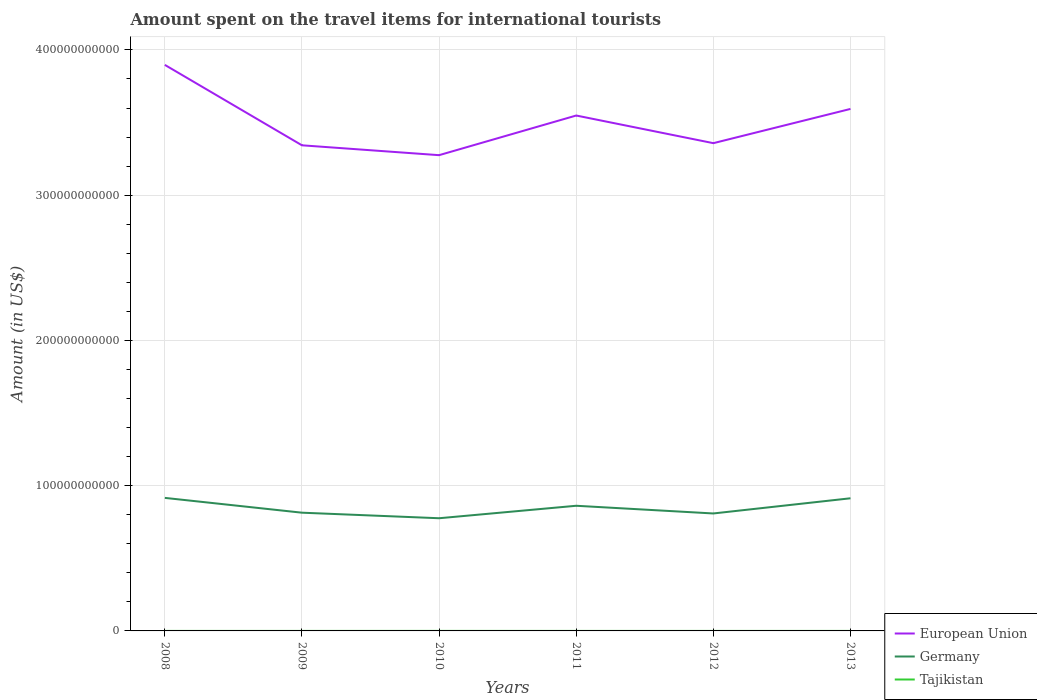Does the line corresponding to European Union intersect with the line corresponding to Germany?
Your answer should be very brief. No. Across all years, what is the maximum amount spent on the travel items for international tourists in European Union?
Your response must be concise. 3.28e+11. In which year was the amount spent on the travel items for international tourists in Germany maximum?
Your answer should be compact. 2010. What is the total amount spent on the travel items for international tourists in Germany in the graph?
Your answer should be compact. -4.76e+09. What is the difference between the highest and the second highest amount spent on the travel items for international tourists in European Union?
Keep it short and to the point. 6.22e+1. What is the difference between two consecutive major ticks on the Y-axis?
Ensure brevity in your answer.  1.00e+11. Are the values on the major ticks of Y-axis written in scientific E-notation?
Offer a terse response. No. How many legend labels are there?
Make the answer very short. 3. What is the title of the graph?
Give a very brief answer. Amount spent on the travel items for international tourists. What is the label or title of the X-axis?
Give a very brief answer. Years. What is the label or title of the Y-axis?
Your answer should be very brief. Amount (in US$). What is the Amount (in US$) of European Union in 2008?
Your answer should be compact. 3.90e+11. What is the Amount (in US$) of Germany in 2008?
Offer a very short reply. 9.16e+1. What is the Amount (in US$) of Tajikistan in 2008?
Make the answer very short. 1.08e+07. What is the Amount (in US$) of European Union in 2009?
Provide a short and direct response. 3.34e+11. What is the Amount (in US$) in Germany in 2009?
Give a very brief answer. 8.14e+1. What is the Amount (in US$) of Tajikistan in 2009?
Your answer should be very brief. 5.80e+06. What is the Amount (in US$) in European Union in 2010?
Your answer should be very brief. 3.28e+11. What is the Amount (in US$) of Germany in 2010?
Provide a succinct answer. 7.76e+1. What is the Amount (in US$) of Tajikistan in 2010?
Provide a short and direct response. 1.78e+07. What is the Amount (in US$) of European Union in 2011?
Offer a terse response. 3.55e+11. What is the Amount (in US$) in Germany in 2011?
Your answer should be compact. 8.62e+1. What is the Amount (in US$) in Tajikistan in 2011?
Give a very brief answer. 8.40e+06. What is the Amount (in US$) in European Union in 2012?
Offer a terse response. 3.36e+11. What is the Amount (in US$) of Germany in 2012?
Provide a succinct answer. 8.09e+1. What is the Amount (in US$) of Tajikistan in 2012?
Your response must be concise. 6.80e+06. What is the Amount (in US$) of European Union in 2013?
Your answer should be very brief. 3.59e+11. What is the Amount (in US$) of Germany in 2013?
Provide a short and direct response. 9.13e+1. What is the Amount (in US$) in Tajikistan in 2013?
Provide a short and direct response. 7.20e+06. Across all years, what is the maximum Amount (in US$) in European Union?
Give a very brief answer. 3.90e+11. Across all years, what is the maximum Amount (in US$) of Germany?
Your response must be concise. 9.16e+1. Across all years, what is the maximum Amount (in US$) in Tajikistan?
Ensure brevity in your answer.  1.78e+07. Across all years, what is the minimum Amount (in US$) of European Union?
Your response must be concise. 3.28e+11. Across all years, what is the minimum Amount (in US$) in Germany?
Provide a short and direct response. 7.76e+1. Across all years, what is the minimum Amount (in US$) of Tajikistan?
Provide a short and direct response. 5.80e+06. What is the total Amount (in US$) in European Union in the graph?
Your answer should be very brief. 2.10e+12. What is the total Amount (in US$) of Germany in the graph?
Keep it short and to the point. 5.09e+11. What is the total Amount (in US$) of Tajikistan in the graph?
Your response must be concise. 5.68e+07. What is the difference between the Amount (in US$) in European Union in 2008 and that in 2009?
Offer a very short reply. 5.54e+1. What is the difference between the Amount (in US$) of Germany in 2008 and that in 2009?
Give a very brief answer. 1.02e+1. What is the difference between the Amount (in US$) in Tajikistan in 2008 and that in 2009?
Give a very brief answer. 5.00e+06. What is the difference between the Amount (in US$) of European Union in 2008 and that in 2010?
Ensure brevity in your answer.  6.22e+1. What is the difference between the Amount (in US$) in Germany in 2008 and that in 2010?
Give a very brief answer. 1.40e+1. What is the difference between the Amount (in US$) of Tajikistan in 2008 and that in 2010?
Keep it short and to the point. -7.00e+06. What is the difference between the Amount (in US$) in European Union in 2008 and that in 2011?
Your answer should be very brief. 3.49e+1. What is the difference between the Amount (in US$) in Germany in 2008 and that in 2011?
Your answer should be compact. 5.43e+09. What is the difference between the Amount (in US$) in Tajikistan in 2008 and that in 2011?
Your response must be concise. 2.40e+06. What is the difference between the Amount (in US$) in European Union in 2008 and that in 2012?
Your answer should be compact. 5.39e+1. What is the difference between the Amount (in US$) in Germany in 2008 and that in 2012?
Offer a very short reply. 1.07e+1. What is the difference between the Amount (in US$) of Tajikistan in 2008 and that in 2012?
Provide a short and direct response. 4.00e+06. What is the difference between the Amount (in US$) of European Union in 2008 and that in 2013?
Make the answer very short. 3.03e+1. What is the difference between the Amount (in US$) of Germany in 2008 and that in 2013?
Your answer should be compact. 2.78e+08. What is the difference between the Amount (in US$) in Tajikistan in 2008 and that in 2013?
Your answer should be very brief. 3.60e+06. What is the difference between the Amount (in US$) in European Union in 2009 and that in 2010?
Your answer should be compact. 6.79e+09. What is the difference between the Amount (in US$) in Germany in 2009 and that in 2010?
Your answer should be very brief. 3.82e+09. What is the difference between the Amount (in US$) in Tajikistan in 2009 and that in 2010?
Offer a terse response. -1.20e+07. What is the difference between the Amount (in US$) in European Union in 2009 and that in 2011?
Give a very brief answer. -2.05e+1. What is the difference between the Amount (in US$) of Germany in 2009 and that in 2011?
Provide a short and direct response. -4.76e+09. What is the difference between the Amount (in US$) in Tajikistan in 2009 and that in 2011?
Offer a terse response. -2.60e+06. What is the difference between the Amount (in US$) of European Union in 2009 and that in 2012?
Ensure brevity in your answer.  -1.47e+09. What is the difference between the Amount (in US$) of Germany in 2009 and that in 2012?
Provide a succinct answer. 5.35e+08. What is the difference between the Amount (in US$) in Tajikistan in 2009 and that in 2012?
Offer a terse response. -1.00e+06. What is the difference between the Amount (in US$) of European Union in 2009 and that in 2013?
Your answer should be compact. -2.50e+1. What is the difference between the Amount (in US$) of Germany in 2009 and that in 2013?
Keep it short and to the point. -9.92e+09. What is the difference between the Amount (in US$) in Tajikistan in 2009 and that in 2013?
Your answer should be very brief. -1.40e+06. What is the difference between the Amount (in US$) of European Union in 2010 and that in 2011?
Provide a short and direct response. -2.73e+1. What is the difference between the Amount (in US$) of Germany in 2010 and that in 2011?
Make the answer very short. -8.59e+09. What is the difference between the Amount (in US$) in Tajikistan in 2010 and that in 2011?
Your answer should be compact. 9.40e+06. What is the difference between the Amount (in US$) in European Union in 2010 and that in 2012?
Provide a succinct answer. -8.26e+09. What is the difference between the Amount (in US$) of Germany in 2010 and that in 2012?
Offer a very short reply. -3.29e+09. What is the difference between the Amount (in US$) of Tajikistan in 2010 and that in 2012?
Provide a succinct answer. 1.10e+07. What is the difference between the Amount (in US$) of European Union in 2010 and that in 2013?
Your answer should be compact. -3.18e+1. What is the difference between the Amount (in US$) of Germany in 2010 and that in 2013?
Provide a succinct answer. -1.37e+1. What is the difference between the Amount (in US$) in Tajikistan in 2010 and that in 2013?
Offer a very short reply. 1.06e+07. What is the difference between the Amount (in US$) in European Union in 2011 and that in 2012?
Offer a very short reply. 1.90e+1. What is the difference between the Amount (in US$) of Germany in 2011 and that in 2012?
Give a very brief answer. 5.30e+09. What is the difference between the Amount (in US$) in Tajikistan in 2011 and that in 2012?
Provide a short and direct response. 1.60e+06. What is the difference between the Amount (in US$) of European Union in 2011 and that in 2013?
Make the answer very short. -4.54e+09. What is the difference between the Amount (in US$) of Germany in 2011 and that in 2013?
Provide a succinct answer. -5.15e+09. What is the difference between the Amount (in US$) in Tajikistan in 2011 and that in 2013?
Offer a very short reply. 1.20e+06. What is the difference between the Amount (in US$) of European Union in 2012 and that in 2013?
Provide a short and direct response. -2.36e+1. What is the difference between the Amount (in US$) of Germany in 2012 and that in 2013?
Provide a short and direct response. -1.05e+1. What is the difference between the Amount (in US$) in Tajikistan in 2012 and that in 2013?
Offer a very short reply. -4.00e+05. What is the difference between the Amount (in US$) in European Union in 2008 and the Amount (in US$) in Germany in 2009?
Keep it short and to the point. 3.08e+11. What is the difference between the Amount (in US$) of European Union in 2008 and the Amount (in US$) of Tajikistan in 2009?
Provide a short and direct response. 3.90e+11. What is the difference between the Amount (in US$) in Germany in 2008 and the Amount (in US$) in Tajikistan in 2009?
Offer a very short reply. 9.16e+1. What is the difference between the Amount (in US$) of European Union in 2008 and the Amount (in US$) of Germany in 2010?
Your response must be concise. 3.12e+11. What is the difference between the Amount (in US$) in European Union in 2008 and the Amount (in US$) in Tajikistan in 2010?
Your answer should be very brief. 3.90e+11. What is the difference between the Amount (in US$) of Germany in 2008 and the Amount (in US$) of Tajikistan in 2010?
Keep it short and to the point. 9.16e+1. What is the difference between the Amount (in US$) of European Union in 2008 and the Amount (in US$) of Germany in 2011?
Your answer should be compact. 3.04e+11. What is the difference between the Amount (in US$) in European Union in 2008 and the Amount (in US$) in Tajikistan in 2011?
Your response must be concise. 3.90e+11. What is the difference between the Amount (in US$) of Germany in 2008 and the Amount (in US$) of Tajikistan in 2011?
Make the answer very short. 9.16e+1. What is the difference between the Amount (in US$) in European Union in 2008 and the Amount (in US$) in Germany in 2012?
Offer a very short reply. 3.09e+11. What is the difference between the Amount (in US$) of European Union in 2008 and the Amount (in US$) of Tajikistan in 2012?
Your answer should be compact. 3.90e+11. What is the difference between the Amount (in US$) in Germany in 2008 and the Amount (in US$) in Tajikistan in 2012?
Keep it short and to the point. 9.16e+1. What is the difference between the Amount (in US$) of European Union in 2008 and the Amount (in US$) of Germany in 2013?
Provide a succinct answer. 2.98e+11. What is the difference between the Amount (in US$) in European Union in 2008 and the Amount (in US$) in Tajikistan in 2013?
Offer a very short reply. 3.90e+11. What is the difference between the Amount (in US$) in Germany in 2008 and the Amount (in US$) in Tajikistan in 2013?
Offer a very short reply. 9.16e+1. What is the difference between the Amount (in US$) in European Union in 2009 and the Amount (in US$) in Germany in 2010?
Keep it short and to the point. 2.57e+11. What is the difference between the Amount (in US$) in European Union in 2009 and the Amount (in US$) in Tajikistan in 2010?
Provide a succinct answer. 3.34e+11. What is the difference between the Amount (in US$) in Germany in 2009 and the Amount (in US$) in Tajikistan in 2010?
Provide a succinct answer. 8.14e+1. What is the difference between the Amount (in US$) of European Union in 2009 and the Amount (in US$) of Germany in 2011?
Provide a short and direct response. 2.48e+11. What is the difference between the Amount (in US$) of European Union in 2009 and the Amount (in US$) of Tajikistan in 2011?
Your answer should be very brief. 3.34e+11. What is the difference between the Amount (in US$) in Germany in 2009 and the Amount (in US$) in Tajikistan in 2011?
Ensure brevity in your answer.  8.14e+1. What is the difference between the Amount (in US$) in European Union in 2009 and the Amount (in US$) in Germany in 2012?
Give a very brief answer. 2.53e+11. What is the difference between the Amount (in US$) in European Union in 2009 and the Amount (in US$) in Tajikistan in 2012?
Provide a short and direct response. 3.34e+11. What is the difference between the Amount (in US$) in Germany in 2009 and the Amount (in US$) in Tajikistan in 2012?
Make the answer very short. 8.14e+1. What is the difference between the Amount (in US$) in European Union in 2009 and the Amount (in US$) in Germany in 2013?
Your response must be concise. 2.43e+11. What is the difference between the Amount (in US$) in European Union in 2009 and the Amount (in US$) in Tajikistan in 2013?
Offer a very short reply. 3.34e+11. What is the difference between the Amount (in US$) in Germany in 2009 and the Amount (in US$) in Tajikistan in 2013?
Provide a short and direct response. 8.14e+1. What is the difference between the Amount (in US$) in European Union in 2010 and the Amount (in US$) in Germany in 2011?
Your answer should be very brief. 2.41e+11. What is the difference between the Amount (in US$) in European Union in 2010 and the Amount (in US$) in Tajikistan in 2011?
Make the answer very short. 3.28e+11. What is the difference between the Amount (in US$) in Germany in 2010 and the Amount (in US$) in Tajikistan in 2011?
Your answer should be very brief. 7.76e+1. What is the difference between the Amount (in US$) of European Union in 2010 and the Amount (in US$) of Germany in 2012?
Provide a succinct answer. 2.47e+11. What is the difference between the Amount (in US$) of European Union in 2010 and the Amount (in US$) of Tajikistan in 2012?
Offer a very short reply. 3.28e+11. What is the difference between the Amount (in US$) in Germany in 2010 and the Amount (in US$) in Tajikistan in 2012?
Your response must be concise. 7.76e+1. What is the difference between the Amount (in US$) of European Union in 2010 and the Amount (in US$) of Germany in 2013?
Offer a very short reply. 2.36e+11. What is the difference between the Amount (in US$) in European Union in 2010 and the Amount (in US$) in Tajikistan in 2013?
Keep it short and to the point. 3.28e+11. What is the difference between the Amount (in US$) in Germany in 2010 and the Amount (in US$) in Tajikistan in 2013?
Your answer should be compact. 7.76e+1. What is the difference between the Amount (in US$) in European Union in 2011 and the Amount (in US$) in Germany in 2012?
Your answer should be compact. 2.74e+11. What is the difference between the Amount (in US$) in European Union in 2011 and the Amount (in US$) in Tajikistan in 2012?
Offer a terse response. 3.55e+11. What is the difference between the Amount (in US$) of Germany in 2011 and the Amount (in US$) of Tajikistan in 2012?
Provide a short and direct response. 8.62e+1. What is the difference between the Amount (in US$) in European Union in 2011 and the Amount (in US$) in Germany in 2013?
Your response must be concise. 2.64e+11. What is the difference between the Amount (in US$) in European Union in 2011 and the Amount (in US$) in Tajikistan in 2013?
Provide a short and direct response. 3.55e+11. What is the difference between the Amount (in US$) in Germany in 2011 and the Amount (in US$) in Tajikistan in 2013?
Make the answer very short. 8.62e+1. What is the difference between the Amount (in US$) in European Union in 2012 and the Amount (in US$) in Germany in 2013?
Keep it short and to the point. 2.44e+11. What is the difference between the Amount (in US$) in European Union in 2012 and the Amount (in US$) in Tajikistan in 2013?
Provide a succinct answer. 3.36e+11. What is the difference between the Amount (in US$) of Germany in 2012 and the Amount (in US$) of Tajikistan in 2013?
Provide a short and direct response. 8.09e+1. What is the average Amount (in US$) in European Union per year?
Give a very brief answer. 3.50e+11. What is the average Amount (in US$) of Germany per year?
Provide a succinct answer. 8.48e+1. What is the average Amount (in US$) in Tajikistan per year?
Make the answer very short. 9.47e+06. In the year 2008, what is the difference between the Amount (in US$) in European Union and Amount (in US$) in Germany?
Keep it short and to the point. 2.98e+11. In the year 2008, what is the difference between the Amount (in US$) in European Union and Amount (in US$) in Tajikistan?
Provide a short and direct response. 3.90e+11. In the year 2008, what is the difference between the Amount (in US$) of Germany and Amount (in US$) of Tajikistan?
Ensure brevity in your answer.  9.16e+1. In the year 2009, what is the difference between the Amount (in US$) of European Union and Amount (in US$) of Germany?
Provide a short and direct response. 2.53e+11. In the year 2009, what is the difference between the Amount (in US$) in European Union and Amount (in US$) in Tajikistan?
Your answer should be compact. 3.34e+11. In the year 2009, what is the difference between the Amount (in US$) of Germany and Amount (in US$) of Tajikistan?
Make the answer very short. 8.14e+1. In the year 2010, what is the difference between the Amount (in US$) of European Union and Amount (in US$) of Germany?
Your answer should be very brief. 2.50e+11. In the year 2010, what is the difference between the Amount (in US$) in European Union and Amount (in US$) in Tajikistan?
Provide a short and direct response. 3.28e+11. In the year 2010, what is the difference between the Amount (in US$) of Germany and Amount (in US$) of Tajikistan?
Offer a very short reply. 7.76e+1. In the year 2011, what is the difference between the Amount (in US$) of European Union and Amount (in US$) of Germany?
Keep it short and to the point. 2.69e+11. In the year 2011, what is the difference between the Amount (in US$) in European Union and Amount (in US$) in Tajikistan?
Keep it short and to the point. 3.55e+11. In the year 2011, what is the difference between the Amount (in US$) in Germany and Amount (in US$) in Tajikistan?
Make the answer very short. 8.62e+1. In the year 2012, what is the difference between the Amount (in US$) in European Union and Amount (in US$) in Germany?
Your answer should be very brief. 2.55e+11. In the year 2012, what is the difference between the Amount (in US$) in European Union and Amount (in US$) in Tajikistan?
Make the answer very short. 3.36e+11. In the year 2012, what is the difference between the Amount (in US$) in Germany and Amount (in US$) in Tajikistan?
Offer a terse response. 8.09e+1. In the year 2013, what is the difference between the Amount (in US$) in European Union and Amount (in US$) in Germany?
Give a very brief answer. 2.68e+11. In the year 2013, what is the difference between the Amount (in US$) of European Union and Amount (in US$) of Tajikistan?
Your response must be concise. 3.59e+11. In the year 2013, what is the difference between the Amount (in US$) in Germany and Amount (in US$) in Tajikistan?
Give a very brief answer. 9.13e+1. What is the ratio of the Amount (in US$) in European Union in 2008 to that in 2009?
Your response must be concise. 1.17. What is the ratio of the Amount (in US$) of Germany in 2008 to that in 2009?
Give a very brief answer. 1.13. What is the ratio of the Amount (in US$) in Tajikistan in 2008 to that in 2009?
Provide a succinct answer. 1.86. What is the ratio of the Amount (in US$) of European Union in 2008 to that in 2010?
Provide a short and direct response. 1.19. What is the ratio of the Amount (in US$) of Germany in 2008 to that in 2010?
Your answer should be very brief. 1.18. What is the ratio of the Amount (in US$) in Tajikistan in 2008 to that in 2010?
Provide a succinct answer. 0.61. What is the ratio of the Amount (in US$) of European Union in 2008 to that in 2011?
Offer a terse response. 1.1. What is the ratio of the Amount (in US$) in Germany in 2008 to that in 2011?
Make the answer very short. 1.06. What is the ratio of the Amount (in US$) in European Union in 2008 to that in 2012?
Provide a short and direct response. 1.16. What is the ratio of the Amount (in US$) of Germany in 2008 to that in 2012?
Provide a succinct answer. 1.13. What is the ratio of the Amount (in US$) of Tajikistan in 2008 to that in 2012?
Make the answer very short. 1.59. What is the ratio of the Amount (in US$) of European Union in 2008 to that in 2013?
Give a very brief answer. 1.08. What is the ratio of the Amount (in US$) in Germany in 2008 to that in 2013?
Keep it short and to the point. 1. What is the ratio of the Amount (in US$) in Tajikistan in 2008 to that in 2013?
Keep it short and to the point. 1.5. What is the ratio of the Amount (in US$) of European Union in 2009 to that in 2010?
Make the answer very short. 1.02. What is the ratio of the Amount (in US$) in Germany in 2009 to that in 2010?
Ensure brevity in your answer.  1.05. What is the ratio of the Amount (in US$) in Tajikistan in 2009 to that in 2010?
Provide a succinct answer. 0.33. What is the ratio of the Amount (in US$) of European Union in 2009 to that in 2011?
Make the answer very short. 0.94. What is the ratio of the Amount (in US$) of Germany in 2009 to that in 2011?
Your response must be concise. 0.94. What is the ratio of the Amount (in US$) in Tajikistan in 2009 to that in 2011?
Provide a succinct answer. 0.69. What is the ratio of the Amount (in US$) of European Union in 2009 to that in 2012?
Your answer should be very brief. 1. What is the ratio of the Amount (in US$) in Germany in 2009 to that in 2012?
Provide a succinct answer. 1.01. What is the ratio of the Amount (in US$) in Tajikistan in 2009 to that in 2012?
Make the answer very short. 0.85. What is the ratio of the Amount (in US$) in European Union in 2009 to that in 2013?
Give a very brief answer. 0.93. What is the ratio of the Amount (in US$) in Germany in 2009 to that in 2013?
Your answer should be very brief. 0.89. What is the ratio of the Amount (in US$) of Tajikistan in 2009 to that in 2013?
Offer a terse response. 0.81. What is the ratio of the Amount (in US$) in Germany in 2010 to that in 2011?
Your answer should be compact. 0.9. What is the ratio of the Amount (in US$) in Tajikistan in 2010 to that in 2011?
Keep it short and to the point. 2.12. What is the ratio of the Amount (in US$) of European Union in 2010 to that in 2012?
Your answer should be compact. 0.98. What is the ratio of the Amount (in US$) of Germany in 2010 to that in 2012?
Your response must be concise. 0.96. What is the ratio of the Amount (in US$) in Tajikistan in 2010 to that in 2012?
Provide a short and direct response. 2.62. What is the ratio of the Amount (in US$) in European Union in 2010 to that in 2013?
Your response must be concise. 0.91. What is the ratio of the Amount (in US$) of Germany in 2010 to that in 2013?
Your response must be concise. 0.85. What is the ratio of the Amount (in US$) in Tajikistan in 2010 to that in 2013?
Make the answer very short. 2.47. What is the ratio of the Amount (in US$) of European Union in 2011 to that in 2012?
Keep it short and to the point. 1.06. What is the ratio of the Amount (in US$) of Germany in 2011 to that in 2012?
Give a very brief answer. 1.07. What is the ratio of the Amount (in US$) in Tajikistan in 2011 to that in 2012?
Offer a very short reply. 1.24. What is the ratio of the Amount (in US$) of European Union in 2011 to that in 2013?
Offer a terse response. 0.99. What is the ratio of the Amount (in US$) of Germany in 2011 to that in 2013?
Make the answer very short. 0.94. What is the ratio of the Amount (in US$) of European Union in 2012 to that in 2013?
Your answer should be compact. 0.93. What is the ratio of the Amount (in US$) of Germany in 2012 to that in 2013?
Provide a short and direct response. 0.89. What is the ratio of the Amount (in US$) of Tajikistan in 2012 to that in 2013?
Keep it short and to the point. 0.94. What is the difference between the highest and the second highest Amount (in US$) in European Union?
Offer a terse response. 3.03e+1. What is the difference between the highest and the second highest Amount (in US$) of Germany?
Give a very brief answer. 2.78e+08. What is the difference between the highest and the second highest Amount (in US$) in Tajikistan?
Make the answer very short. 7.00e+06. What is the difference between the highest and the lowest Amount (in US$) in European Union?
Your answer should be compact. 6.22e+1. What is the difference between the highest and the lowest Amount (in US$) in Germany?
Your answer should be very brief. 1.40e+1. What is the difference between the highest and the lowest Amount (in US$) in Tajikistan?
Provide a short and direct response. 1.20e+07. 